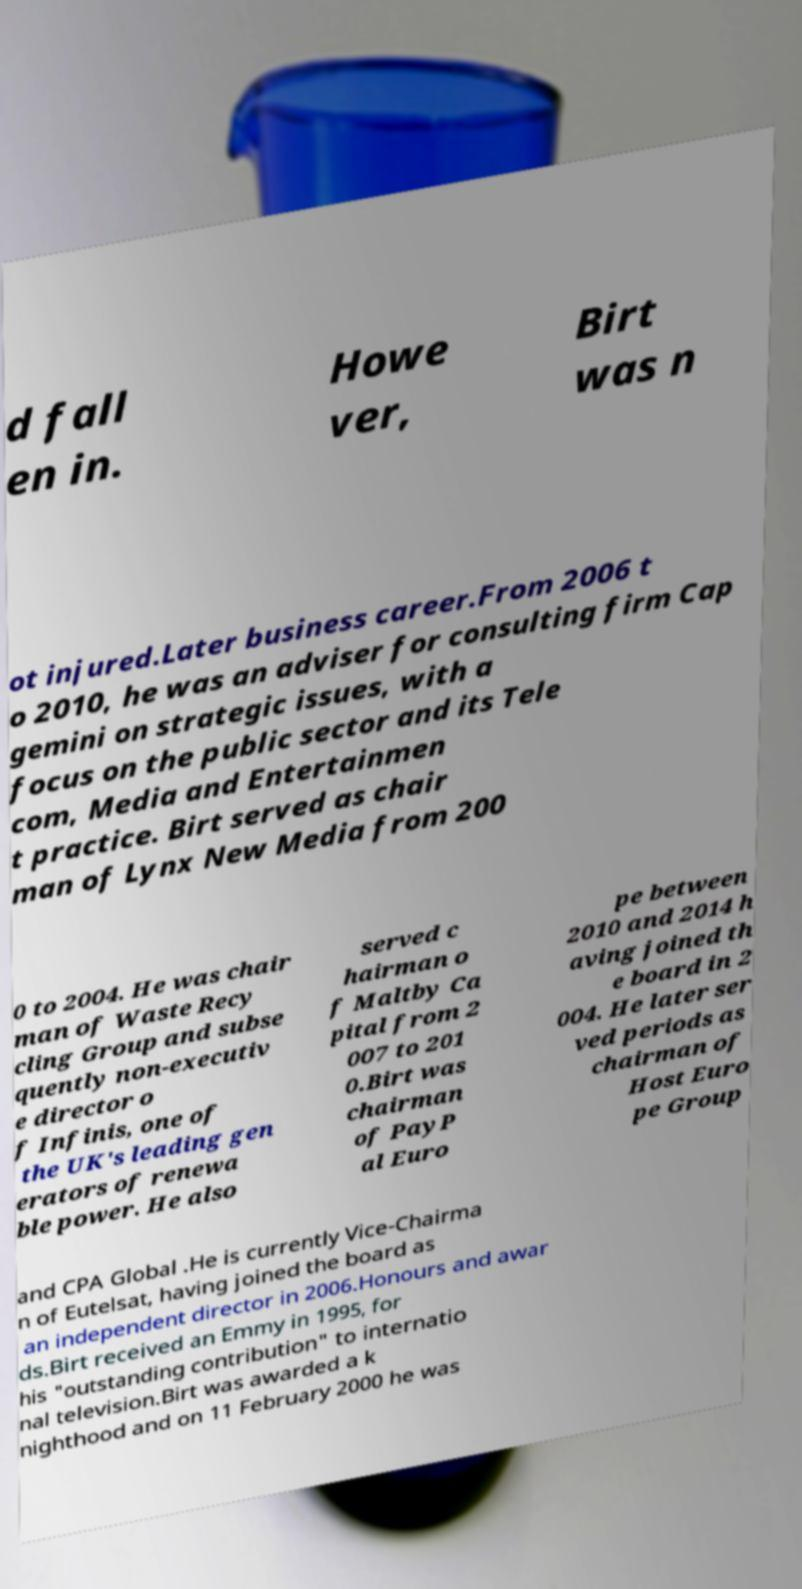Please identify and transcribe the text found in this image. d fall en in. Howe ver, Birt was n ot injured.Later business career.From 2006 t o 2010, he was an adviser for consulting firm Cap gemini on strategic issues, with a focus on the public sector and its Tele com, Media and Entertainmen t practice. Birt served as chair man of Lynx New Media from 200 0 to 2004. He was chair man of Waste Recy cling Group and subse quently non-executiv e director o f Infinis, one of the UK's leading gen erators of renewa ble power. He also served c hairman o f Maltby Ca pital from 2 007 to 201 0.Birt was chairman of PayP al Euro pe between 2010 and 2014 h aving joined th e board in 2 004. He later ser ved periods as chairman of Host Euro pe Group and CPA Global .He is currently Vice-Chairma n of Eutelsat, having joined the board as an independent director in 2006.Honours and awar ds.Birt received an Emmy in 1995, for his "outstanding contribution" to internatio nal television.Birt was awarded a k nighthood and on 11 February 2000 he was 